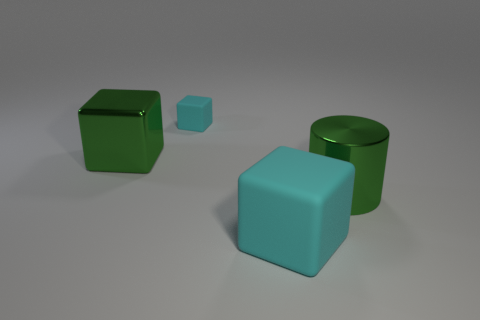Are there fewer big cyan objects that are in front of the tiny cyan cube than green shiny blocks right of the big cyan thing?
Your answer should be compact. No. Do the small object and the big rubber thing have the same shape?
Your response must be concise. Yes. What number of matte blocks are the same size as the green metallic cube?
Make the answer very short. 1. Are there fewer metal things behind the tiny cyan matte block than tiny cyan matte things?
Your response must be concise. Yes. How big is the green shiny object in front of the big cube left of the small cyan block?
Keep it short and to the point. Large. How many objects are gray metallic cubes or blocks?
Keep it short and to the point. 3. Is there a thing that has the same color as the metallic block?
Ensure brevity in your answer.  Yes. Is the number of green things less than the number of large blue balls?
Provide a short and direct response. No. What number of objects are either big cyan rubber things or green shiny things that are to the left of the large cyan object?
Offer a terse response. 2. Is there a large green object made of the same material as the cylinder?
Offer a terse response. Yes. 